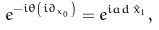<formula> <loc_0><loc_0><loc_500><loc_500>e ^ { - i \theta \left ( i \partial _ { x _ { 0 } } \right ) } = e ^ { i a d \, \hat { x } _ { 1 } } \, ,</formula> 